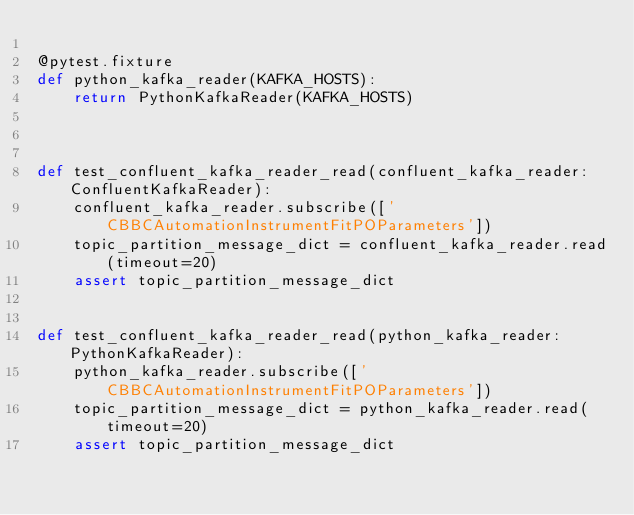<code> <loc_0><loc_0><loc_500><loc_500><_Python_>
@pytest.fixture
def python_kafka_reader(KAFKA_HOSTS):
    return PythonKafkaReader(KAFKA_HOSTS)



def test_confluent_kafka_reader_read(confluent_kafka_reader: ConfluentKafkaReader):
    confluent_kafka_reader.subscribe(['CBBCAutomationInstrumentFitPOParameters'])
    topic_partition_message_dict = confluent_kafka_reader.read(timeout=20)
    assert topic_partition_message_dict


def test_confluent_kafka_reader_read(python_kafka_reader: PythonKafkaReader):
    python_kafka_reader.subscribe(['CBBCAutomationInstrumentFitPOParameters'])
    topic_partition_message_dict = python_kafka_reader.read(timeout=20)
    assert topic_partition_message_dict
</code> 